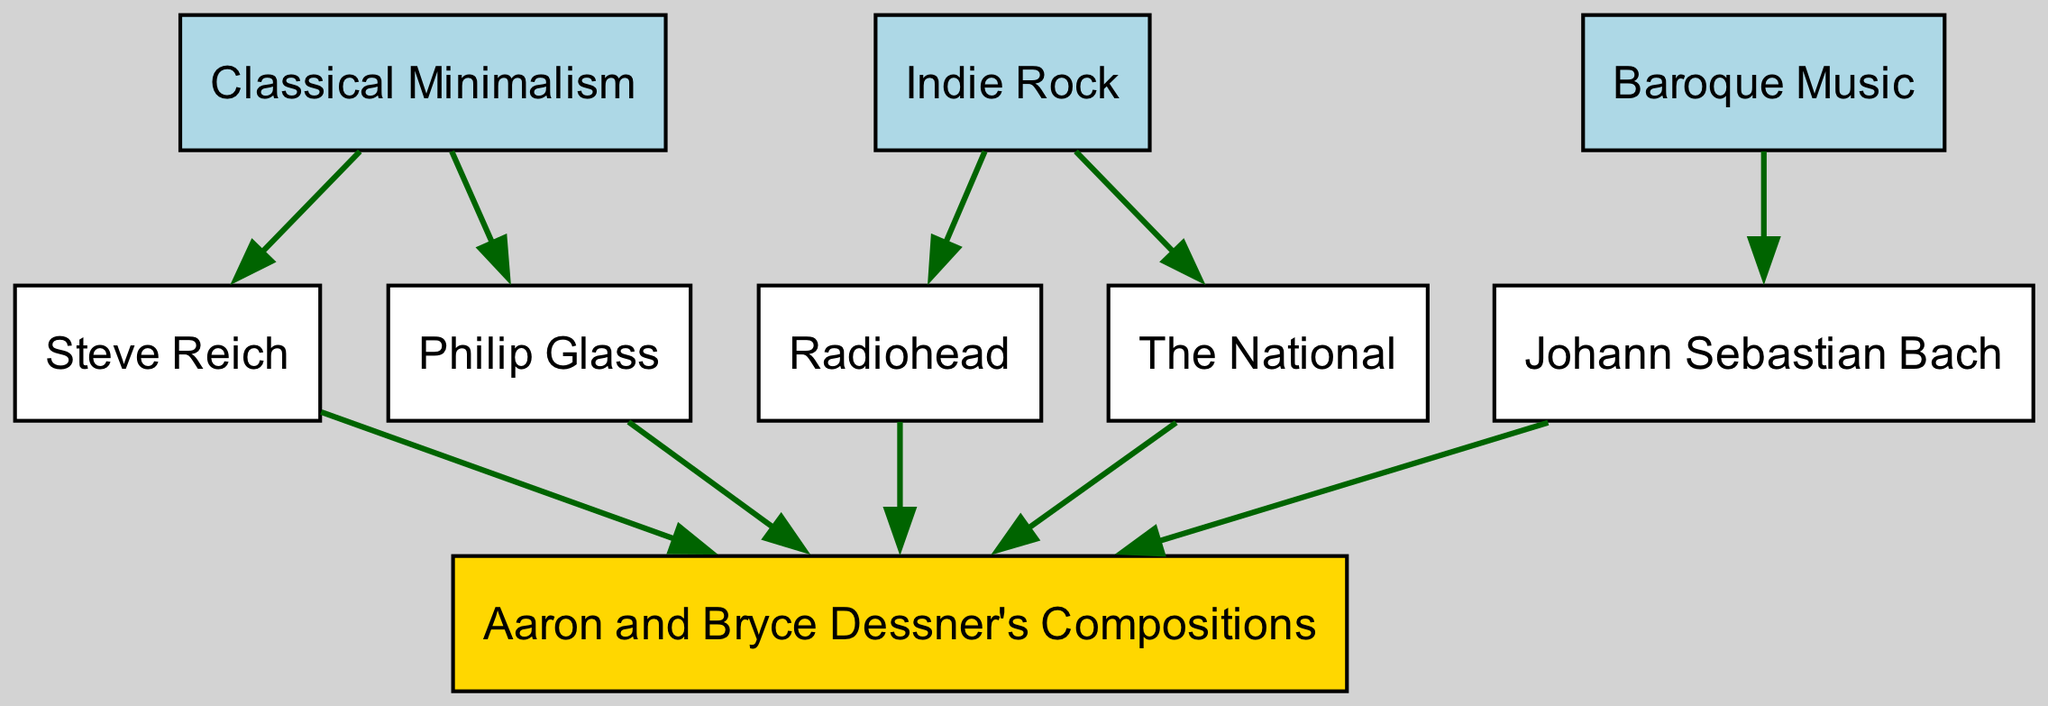What are the main categories of musical influences on Aaron and Bryce Dessner's compositions? The diagram shows three main categories of musical influences: Classical Minimalism, Indie Rock, and Baroque Music. These three categories are distinctly labeled and represented in the diagram.
Answer: Classical Minimalism, Indie Rock, Baroque Music How many total nodes are present in the diagram? By counting all unique musical influences and the final composition node, we identify a total of 8 nodes. These include Classical Minimalism, Steve Reich, Philip Glass, Indie Rock, Radiohead, The National, Baroque Music, and Johann Sebastian Bach, plus Aaron and Bryce Dessner's Compositions.
Answer: 8 Which node is directly influenced by Johann Sebastian Bach? According to the diagram, Johann Sebastian Bach has a direct influence on Aaron and Bryce Dessner's Compositions, as indicated by an edge flowing from Bach to their compositions.
Answer: Aaron and Bryce Dessner's Compositions What two composers are associated with Classical Minimalism? The diagram highlights two key figures within the Classical Minimalism category: Steve Reich and Philip Glass. Both nodes are connected to the Classical Minimalism node.
Answer: Steve Reich, Philip Glass Which band links Indie Rock to Aaron and Bryce Dessner's compositions? The diagram shows that Radiohead and The National are directly linked to Aaron and Bryce Dessner's Compositions via edges from the Indie Rock node. This indicates both bands influence Dessner's work.
Answer: Radiohead, The National What is the relationship between Classical Minimalism and the compositions of Aaron and Bryce Dessner? The diagram illustrates that both Steve Reich and Philip Glass, influential figures of Classical Minimalism, have directed edges leading to Aaron and Bryce Dessner's Compositions. This indicates their compositions are significantly impacted by the principles of Classical Minimalism.
Answer: Influenced by Steve Reich and Philip Glass How many direct influences come from Indie Rock to Aaron and Bryce Dessner's Compositions? Analyzing the diagram, there are two direct influences from Indie Rock: one from Radiohead and the other from The National, both of which point to Aaron and Bryce Dessner's Compositions.
Answer: 2 What type of music does Johann Sebastian Bach represent in the diagram? Johann Sebastian Bach is categorized under Baroque Music, as indicated by the direct relationship shown in the diagram between Baroque Music and Bach.
Answer: Baroque Music Which genre connects Steve Reich and Philip Glass to Aaron and Bryce Dessner's Compositions? The connection from both Steve Reich and Philip Glass to Aaron and Bryce Dessner's Compositions is drawn from the genre of Classical Minimalism, which serves as the parent influence in the diagram.
Answer: Classical Minimalism 